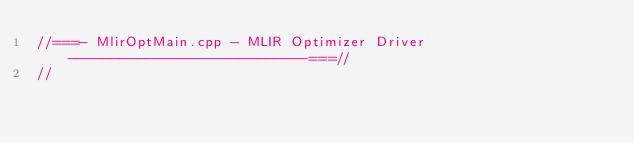<code> <loc_0><loc_0><loc_500><loc_500><_C++_>//===- MlirOptMain.cpp - MLIR Optimizer Driver ----------------------------===//
//</code> 